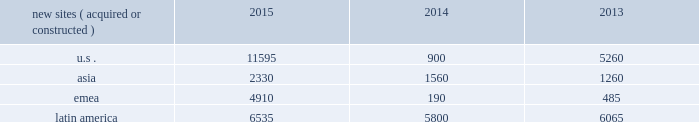The long term .
In addition , we have focused on building relationships with large multinational carriers such as airtel , telef f3nica s.a .
And vodafone group plc .
We believe that consistent carrier investments in their networks across our international markets position us to generate meaningful organic revenue growth going forward .
In emerging markets , such as ghana , india , nigeria and uganda , wireless networks tend to be significantly less advanced than those in the united states , and initial voice networks continue to be deployed in underdeveloped areas .
A majority of consumers in these markets still utilize basic wireless services , predominantly on feature phones , while advanced device penetration remains low .
In more developed urban locations within these markets , early-stage data network deployments are underway .
Carriers are focused on completing voice network build-outs while also investing in initial data networks as wireless data usage and smartphone penetration within their customer bases begin to accelerate .
In markets with rapidly evolving network technology , such as south africa and most of the countries in latin america where we do business , initial voice networks , for the most part , have already been built out , and carriers are focused on 3g network build outs , with select investments in 4g technology .
Consumers in these regions are increasingly adopting smartphones and other advanced devices , and as a result , the usage of bandwidth-intensive mobile applications is growing materially .
Recent spectrum auctions in these rapidly evolving markets have allowed incumbent carriers to accelerate their data network deployments and have also enabled new entrants to begin initial investments in data networks .
Smartphone penetration and wireless data usage in these markets are growing rapidly , which typically requires that carriers continue to invest in their networks in order to maintain and augment their quality of service .
Finally , in markets with more mature network technology , such as germany , carriers are focused on deploying 4g data networks to account for rapidly increasing wireless data usage amongst their customer base .
With higher smartphone and advanced device penetration and significantly higher per capita data usage , carrier investment in networks is focused on 4g coverage and capacity .
We believe that the network technology migration we have seen in the united states , which has led to significantly denser networks and meaningful new business commencements for us over a number of years , will ultimately be replicated in our less advanced international markets .
As a result , we expect to be able to leverage our extensive international portfolio of approximately 60190 communications sites and the relationships we have built with our carrier customers to drive sustainable , long-term growth .
We have holistic master lease agreements with certain of our tenants that provide for consistent , long-term revenue and a reduction in the likelihood of churn .
Our holistic master lease agreements build and augment strong strategic partnerships with our tenants and have significantly reduced collocation cycle times , thereby providing our tenants with the ability to rapidly and efficiently deploy equipment on our sites .
Property operations new site revenue growth .
During the year ended december 31 , 2015 , we grew our portfolio of communications real estate through the acquisition and construction of approximately 25370 sites .
In a majority of our asia , emea and latin america markets , the acquisition or construction of new sites resulted in increases in both tenant and pass- through revenues ( such as ground rent or power and fuel costs ) and expenses .
We continue to evaluate opportunities to acquire communications real estate portfolios , both domestically and internationally , to determine whether they meet our risk-adjusted hurdle rates and whether we believe we can effectively integrate them into our existing portfolio. .
Property operations expenses .
Direct operating expenses incurred by our property segments include direct site level expenses and consist primarily of ground rent and power and fuel costs , some or all of which may be passed through to our tenants , as well as property taxes , repairs and maintenance .
These segment direct operating expenses exclude all segment and corporate selling , general , administrative and development expenses , which are aggregated into one line item entitled selling , general , administrative and development expense in our consolidated statements of operations .
In general , our property segments 2019 selling , general , administrative and development expenses do not significantly increase as a result of adding incremental tenants to our legacy sites and typically increase only modestly year-over-year .
As a result , leasing additional space to new tenants on our legacy sites provides significant incremental cash flow .
We may , however , incur additional segment .
What was the percentage of the real estate portfolios for asia from 2014 to 2015? 
Computations: ((2330 - 1560) / 1560)
Answer: 0.49359. The long term .
In addition , we have focused on building relationships with large multinational carriers such as airtel , telef f3nica s.a .
And vodafone group plc .
We believe that consistent carrier investments in their networks across our international markets position us to generate meaningful organic revenue growth going forward .
In emerging markets , such as ghana , india , nigeria and uganda , wireless networks tend to be significantly less advanced than those in the united states , and initial voice networks continue to be deployed in underdeveloped areas .
A majority of consumers in these markets still utilize basic wireless services , predominantly on feature phones , while advanced device penetration remains low .
In more developed urban locations within these markets , early-stage data network deployments are underway .
Carriers are focused on completing voice network build-outs while also investing in initial data networks as wireless data usage and smartphone penetration within their customer bases begin to accelerate .
In markets with rapidly evolving network technology , such as south africa and most of the countries in latin america where we do business , initial voice networks , for the most part , have already been built out , and carriers are focused on 3g network build outs , with select investments in 4g technology .
Consumers in these regions are increasingly adopting smartphones and other advanced devices , and as a result , the usage of bandwidth-intensive mobile applications is growing materially .
Recent spectrum auctions in these rapidly evolving markets have allowed incumbent carriers to accelerate their data network deployments and have also enabled new entrants to begin initial investments in data networks .
Smartphone penetration and wireless data usage in these markets are growing rapidly , which typically requires that carriers continue to invest in their networks in order to maintain and augment their quality of service .
Finally , in markets with more mature network technology , such as germany , carriers are focused on deploying 4g data networks to account for rapidly increasing wireless data usage amongst their customer base .
With higher smartphone and advanced device penetration and significantly higher per capita data usage , carrier investment in networks is focused on 4g coverage and capacity .
We believe that the network technology migration we have seen in the united states , which has led to significantly denser networks and meaningful new business commencements for us over a number of years , will ultimately be replicated in our less advanced international markets .
As a result , we expect to be able to leverage our extensive international portfolio of approximately 60190 communications sites and the relationships we have built with our carrier customers to drive sustainable , long-term growth .
We have holistic master lease agreements with certain of our tenants that provide for consistent , long-term revenue and a reduction in the likelihood of churn .
Our holistic master lease agreements build and augment strong strategic partnerships with our tenants and have significantly reduced collocation cycle times , thereby providing our tenants with the ability to rapidly and efficiently deploy equipment on our sites .
Property operations new site revenue growth .
During the year ended december 31 , 2015 , we grew our portfolio of communications real estate through the acquisition and construction of approximately 25370 sites .
In a majority of our asia , emea and latin america markets , the acquisition or construction of new sites resulted in increases in both tenant and pass- through revenues ( such as ground rent or power and fuel costs ) and expenses .
We continue to evaluate opportunities to acquire communications real estate portfolios , both domestically and internationally , to determine whether they meet our risk-adjusted hurdle rates and whether we believe we can effectively integrate them into our existing portfolio. .
Property operations expenses .
Direct operating expenses incurred by our property segments include direct site level expenses and consist primarily of ground rent and power and fuel costs , some or all of which may be passed through to our tenants , as well as property taxes , repairs and maintenance .
These segment direct operating expenses exclude all segment and corporate selling , general , administrative and development expenses , which are aggregated into one line item entitled selling , general , administrative and development expense in our consolidated statements of operations .
In general , our property segments 2019 selling , general , administrative and development expenses do not significantly increase as a result of adding incremental tenants to our legacy sites and typically increase only modestly year-over-year .
As a result , leasing additional space to new tenants on our legacy sites provides significant incremental cash flow .
We may , however , incur additional segment .
What is the total number of sites acquired and constructed during 2015? 
Computations: (((11595 + 2330) + 4910) + 6535)
Answer: 25370.0. 